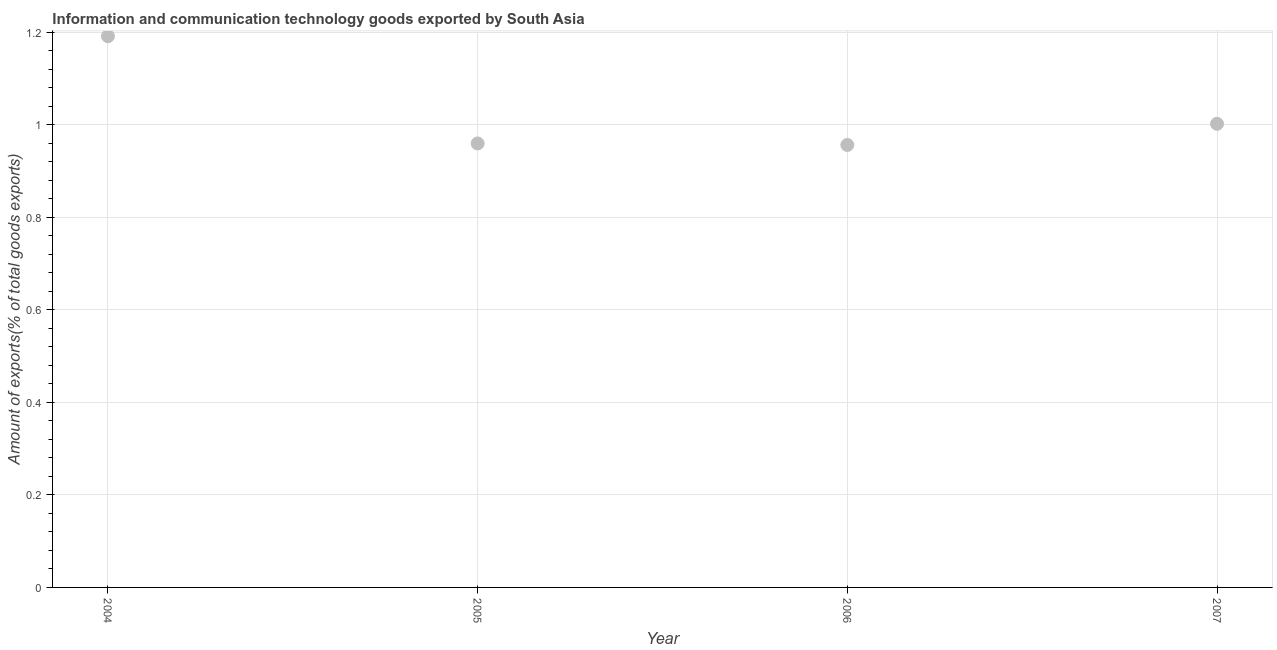What is the amount of ict goods exports in 2005?
Make the answer very short. 0.96. Across all years, what is the maximum amount of ict goods exports?
Your answer should be very brief. 1.19. Across all years, what is the minimum amount of ict goods exports?
Provide a short and direct response. 0.96. In which year was the amount of ict goods exports minimum?
Keep it short and to the point. 2006. What is the sum of the amount of ict goods exports?
Offer a terse response. 4.11. What is the difference between the amount of ict goods exports in 2005 and 2006?
Make the answer very short. 0. What is the average amount of ict goods exports per year?
Keep it short and to the point. 1.03. What is the median amount of ict goods exports?
Keep it short and to the point. 0.98. In how many years, is the amount of ict goods exports greater than 0.88 %?
Give a very brief answer. 4. What is the ratio of the amount of ict goods exports in 2004 to that in 2006?
Provide a short and direct response. 1.25. Is the difference between the amount of ict goods exports in 2004 and 2005 greater than the difference between any two years?
Your answer should be very brief. No. What is the difference between the highest and the second highest amount of ict goods exports?
Offer a terse response. 0.19. Is the sum of the amount of ict goods exports in 2005 and 2006 greater than the maximum amount of ict goods exports across all years?
Offer a terse response. Yes. What is the difference between the highest and the lowest amount of ict goods exports?
Ensure brevity in your answer.  0.24. In how many years, is the amount of ict goods exports greater than the average amount of ict goods exports taken over all years?
Your answer should be very brief. 1. Does the amount of ict goods exports monotonically increase over the years?
Offer a terse response. No. How many dotlines are there?
Make the answer very short. 1. How many years are there in the graph?
Offer a terse response. 4. Are the values on the major ticks of Y-axis written in scientific E-notation?
Offer a terse response. No. Does the graph contain grids?
Your response must be concise. Yes. What is the title of the graph?
Ensure brevity in your answer.  Information and communication technology goods exported by South Asia. What is the label or title of the X-axis?
Your answer should be compact. Year. What is the label or title of the Y-axis?
Give a very brief answer. Amount of exports(% of total goods exports). What is the Amount of exports(% of total goods exports) in 2004?
Offer a very short reply. 1.19. What is the Amount of exports(% of total goods exports) in 2005?
Your answer should be compact. 0.96. What is the Amount of exports(% of total goods exports) in 2006?
Your response must be concise. 0.96. What is the Amount of exports(% of total goods exports) in 2007?
Keep it short and to the point. 1. What is the difference between the Amount of exports(% of total goods exports) in 2004 and 2005?
Offer a very short reply. 0.23. What is the difference between the Amount of exports(% of total goods exports) in 2004 and 2006?
Offer a terse response. 0.24. What is the difference between the Amount of exports(% of total goods exports) in 2004 and 2007?
Your answer should be compact. 0.19. What is the difference between the Amount of exports(% of total goods exports) in 2005 and 2006?
Your response must be concise. 0. What is the difference between the Amount of exports(% of total goods exports) in 2005 and 2007?
Offer a terse response. -0.04. What is the difference between the Amount of exports(% of total goods exports) in 2006 and 2007?
Offer a terse response. -0.05. What is the ratio of the Amount of exports(% of total goods exports) in 2004 to that in 2005?
Provide a succinct answer. 1.24. What is the ratio of the Amount of exports(% of total goods exports) in 2004 to that in 2006?
Your response must be concise. 1.25. What is the ratio of the Amount of exports(% of total goods exports) in 2004 to that in 2007?
Your answer should be very brief. 1.19. What is the ratio of the Amount of exports(% of total goods exports) in 2005 to that in 2007?
Offer a terse response. 0.96. What is the ratio of the Amount of exports(% of total goods exports) in 2006 to that in 2007?
Provide a short and direct response. 0.95. 